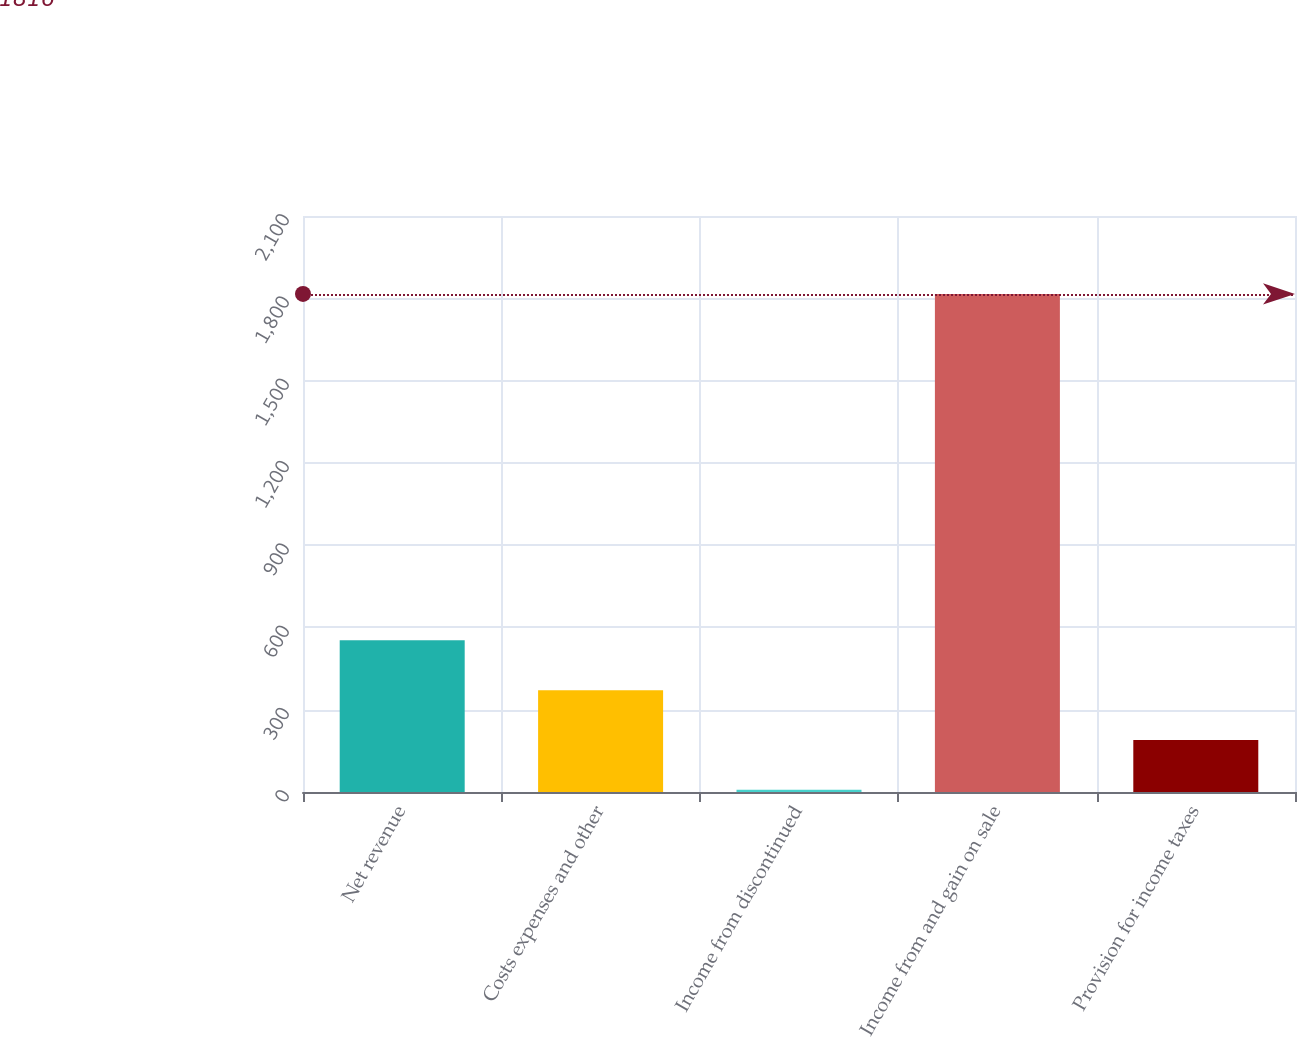<chart> <loc_0><loc_0><loc_500><loc_500><bar_chart><fcel>Net revenue<fcel>Costs expenses and other<fcel>Income from discontinued<fcel>Income from and gain on sale<fcel>Provision for income taxes<nl><fcel>552.8<fcel>371.2<fcel>8<fcel>1816<fcel>189.6<nl></chart> 